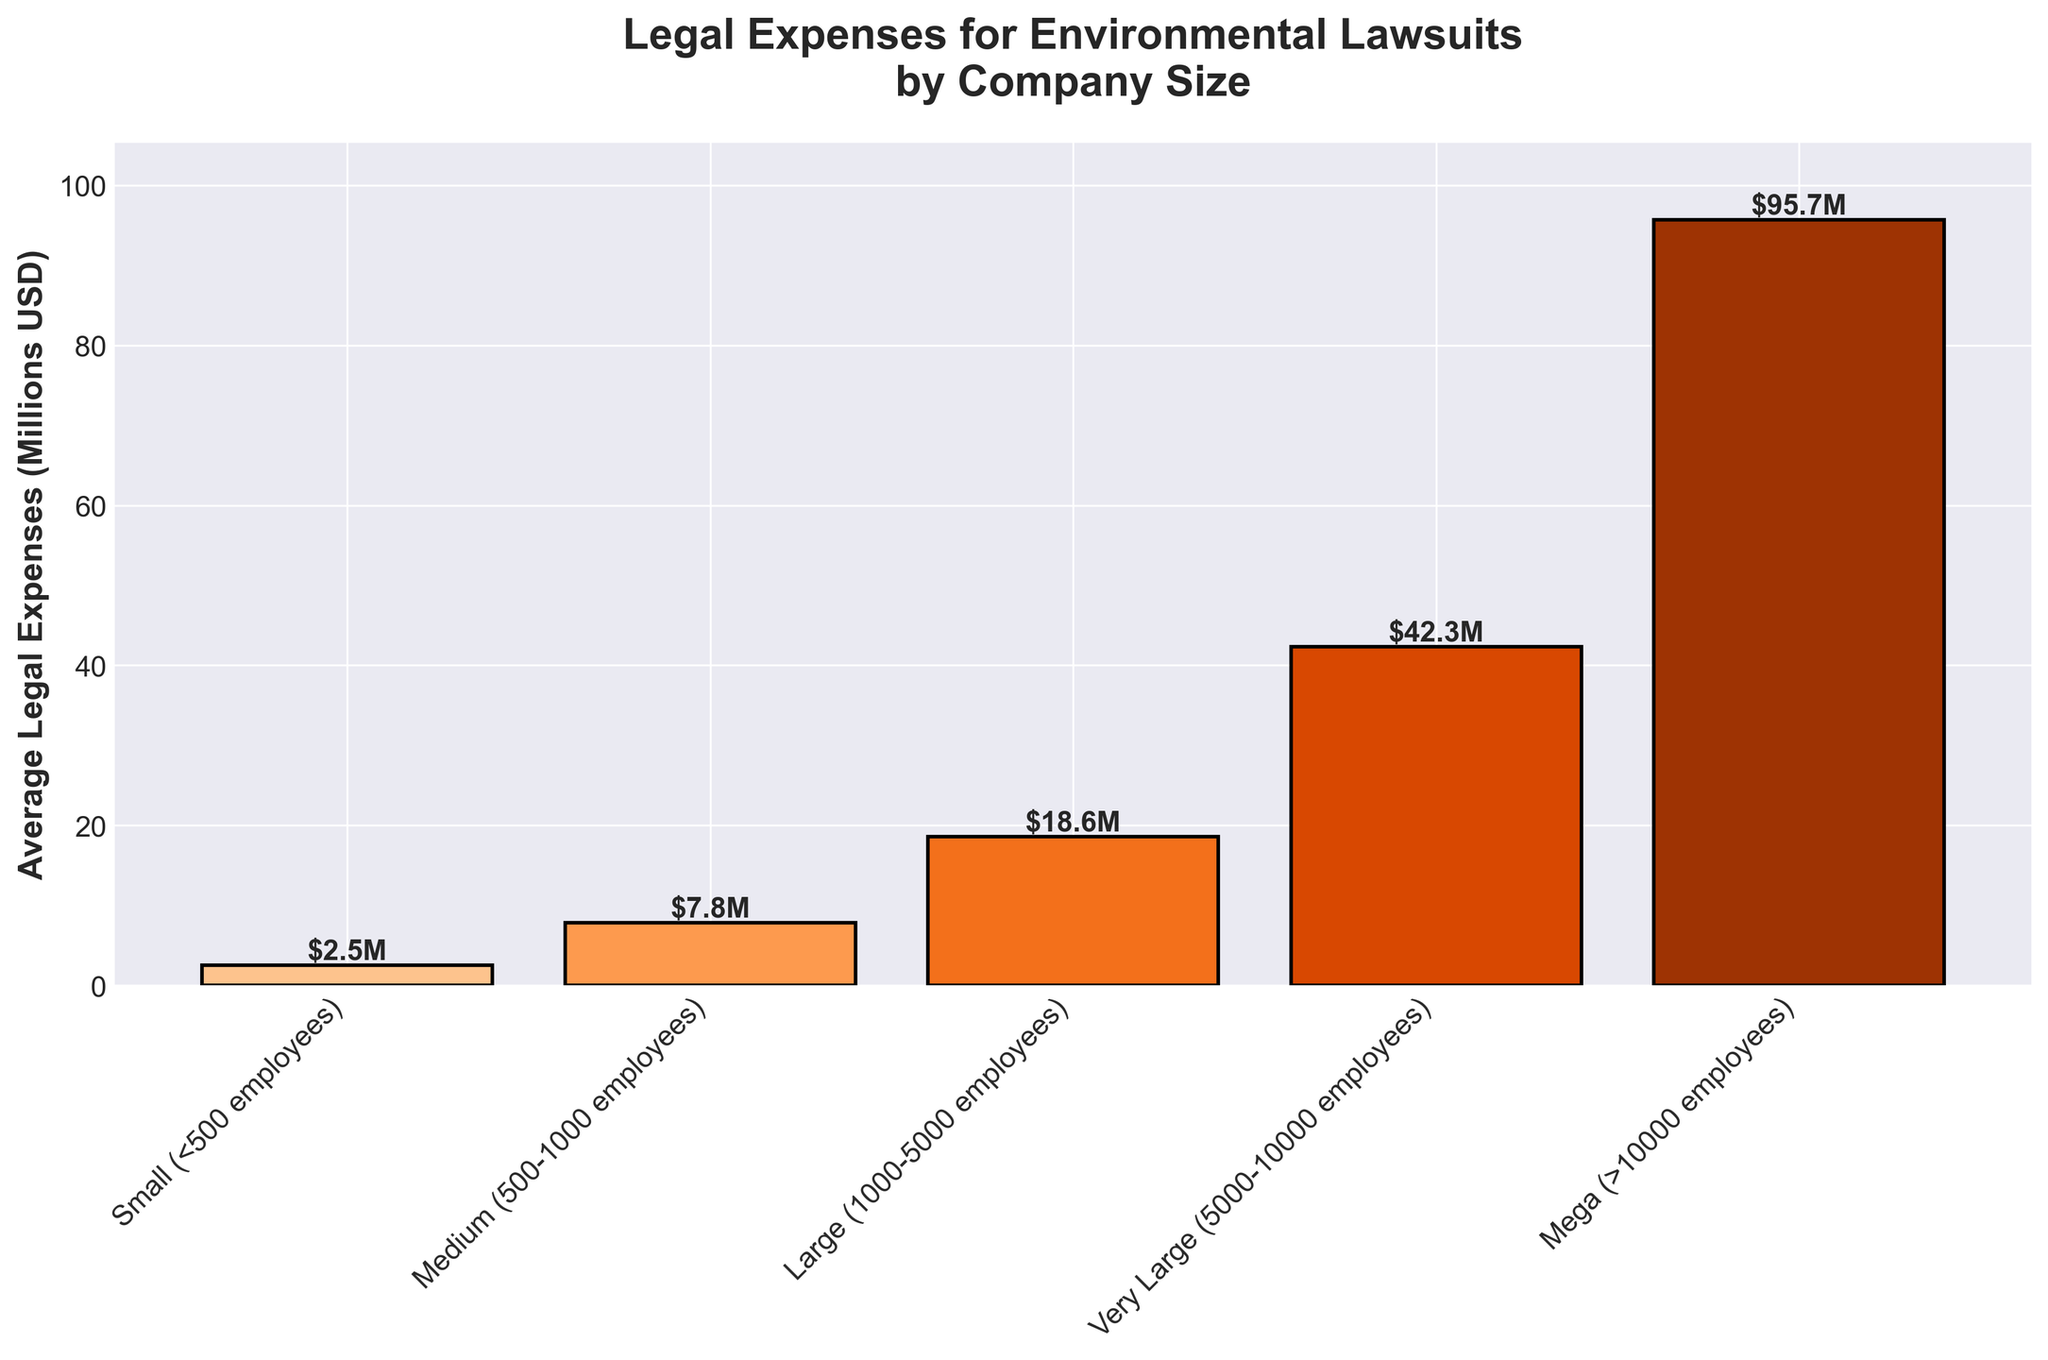How much more are the average legal expenses for Mega companies compared to Very Large companies? To determine the difference, identify the legal expenses for Mega and Very Large companies. The Mega companies have an expense of 95.7 million USD and Very Large companies have an expense of 42.3 million USD. Subtract the expense of Very Large companies from that of Mega companies (95.7 - 42.3).
Answer: 53.4 million USD Which company size has the lowest average legal expenses? Analyze the bars in the figure and identify the bar with the shortest height. In this case, the Small company size has the lowest bar height.
Answer: Small (<500 employees) What is the combined total of average legal expenses for Small, Medium, and Large companies? Sum the average legal expenses of Small (2.5 million USD), Medium (7.8 million USD), and Large (18.6 million USD) companies. The combined total is (2.5 + 7.8 + 18.6).
Answer: 28.9 million USD Between Large and Very Large companies, which has higher average legal expenses, and by how much? Identify the expenses of Large (18.6 million USD) and Very Large (42.3 million USD) companies. Subtract the expenses of the Large companies from those of the Very Large ones (42.3 - 18.6).
Answer: Very Large by 23.7 million USD What is the percentage increase in legal expenses when moving from Medium to Large companies? Identify the expenses for Medium (7.8 million USD) and Large (18.6 million USD) companies. Calculate the percentage increase using the formula: ((18.6 - 7.8) / 7.8) * 100.
Answer: ~138.5% If Small and Medium companies are combined, do their total average legal expenses match or exceed those of Large companies? Calculate the combined expenses of Small (2.5 million USD) and Medium (7.8 million USD) companies. Compare this sum (2.5 + 7.8 = 10.3 million USD) with the expenses of Large companies (18.6 million USD).
Answer: Not exceeding Among the Medium, Large, and Very Large companies, which one has the highest average legal expenses? Compare the bar heights for Medium (7.8 million USD), Large (18.6 million USD), and Very Large (42.3 million USD) companies. Very Large companies have the highest bar.
Answer: Very Large How much is the difference in the average legal expenses between the highest and lowest company sizes represented? Identify the expenses of the highest (Mega, 95.7 million USD) and the lowest (Small, 2.5 million USD) companies. Subtract the smallest value from the largest (95.7 - 2.5).
Answer: 93.2 million USD 